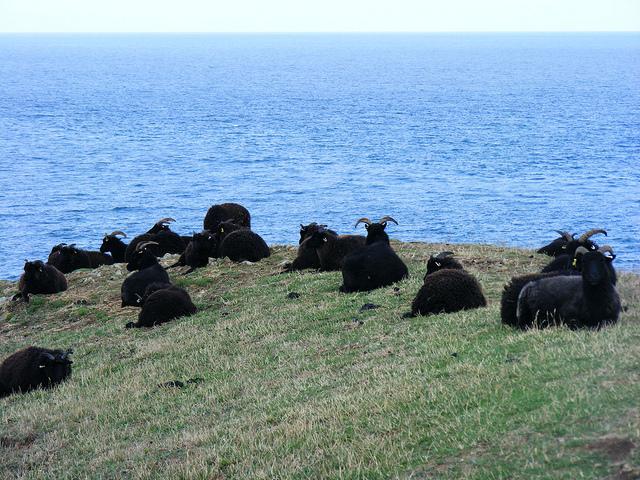Are these mammals?
Keep it brief. Yes. Are the sheep content?
Answer briefly. Yes. What kind of livestock is this?
Give a very brief answer. Goats. 